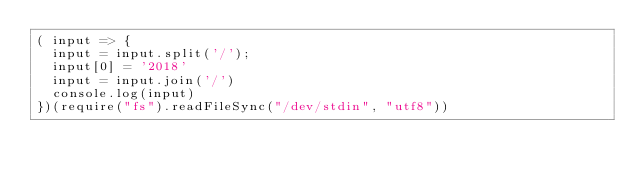<code> <loc_0><loc_0><loc_500><loc_500><_JavaScript_>( input => {
  input = input.split('/');
  input[0] = '2018'
  input = input.join('/')
  console.log(input)
})(require("fs").readFileSync("/dev/stdin", "utf8"))</code> 